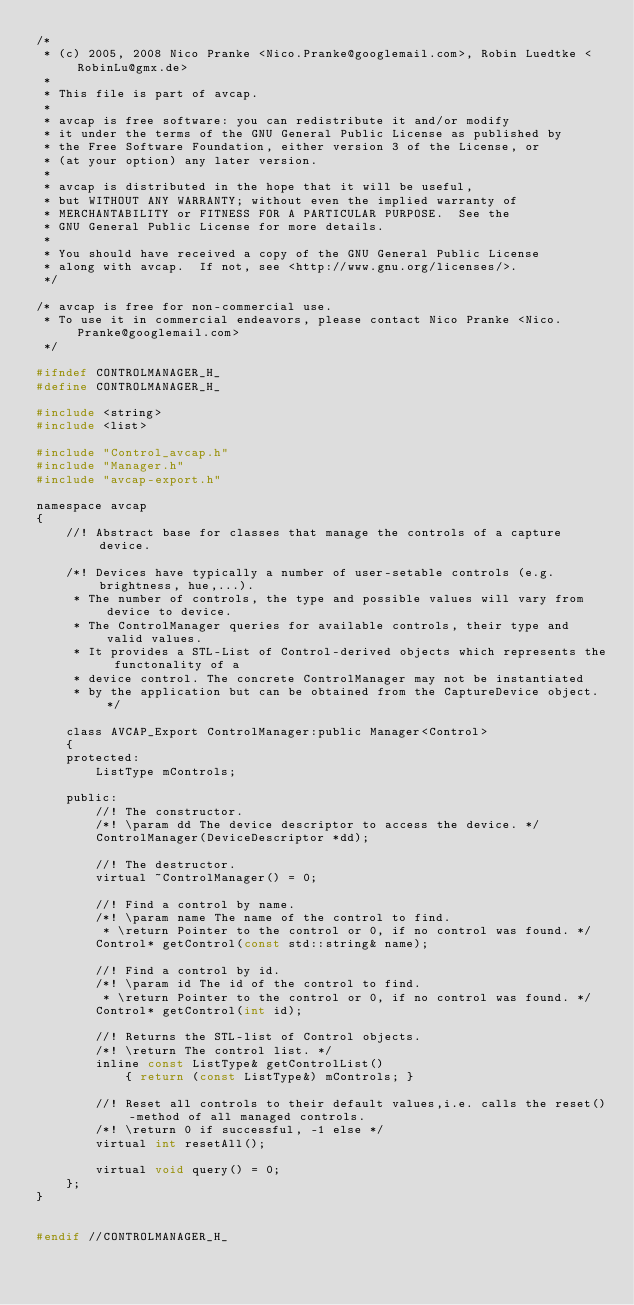<code> <loc_0><loc_0><loc_500><loc_500><_C_>/*
 * (c) 2005, 2008 Nico Pranke <Nico.Pranke@googlemail.com>, Robin Luedtke <RobinLu@gmx.de> 
 *
 * This file is part of avcap.
 *
 * avcap is free software: you can redistribute it and/or modify
 * it under the terms of the GNU General Public License as published by
 * the Free Software Foundation, either version 3 of the License, or
 * (at your option) any later version.
 *
 * avcap is distributed in the hope that it will be useful,
 * but WITHOUT ANY WARRANTY; without even the implied warranty of
 * MERCHANTABILITY or FITNESS FOR A PARTICULAR PURPOSE.  See the
 * GNU General Public License for more details.
 *
 * You should have received a copy of the GNU General Public License
 * along with avcap.  If not, see <http://www.gnu.org/licenses/>.
 */

/* avcap is free for non-commercial use.
 * To use it in commercial endeavors, please contact Nico Pranke <Nico.Pranke@googlemail.com>
 */

#ifndef CONTROLMANAGER_H_
#define CONTROLMANAGER_H_

#include <string>
#include <list>

#include "Control_avcap.h"
#include "Manager.h"
#include "avcap-export.h"

namespace avcap
{
	//! Abstract base for classes that manage the controls of a capture device.
	
	/*! Devices have typically a number of user-setable controls (e.g. brightness, hue,...).
	 * The number of controls, the type and possible values will vary from device to device.
	 * The ControlManager queries for available controls, their type and valid values.
	 * It provides a STL-List of Control-derived objects which represents the functonality of a
	 * device control. The concrete ControlManager may not be instantiated
	 * by the application but can be obtained from the CaptureDevice object. */
	
	class AVCAP_Export ControlManager:public Manager<Control>
	{
	protected:
		ListType mControls;
	
	public:
		//! The constructor. 
		/*! \param dd The device descriptor to access the device. */
		ControlManager(DeviceDescriptor *dd);
	
		//! The destructor.
		virtual ~ControlManager() = 0;
	
		//! Find a control by name.
		/*! \param name The name of the control to find.
		 * \return Pointer to the control or 0, if no control was found. */
		Control* getControl(const std::string& name);
	
		//! Find a control by id.
		/*! \param id The id of the control to find.
		 * \return Pointer to the control or 0, if no control was found. */
		Control* getControl(int id);
	
		//! Returns the STL-list of Control objects.
		/*! \return The control list. */
		inline const ListType& getControlList() 
			{ return (const ListType&) mControls; }
	
		//! Reset all controls to their default values,i.e. calls the reset()-method of all managed controls.
		/*! \return 0 if successful, -1 else */
		virtual int resetAll();
	
		virtual void query() = 0;
	};
}


#endif //CONTROLMANAGER_H_
</code> 